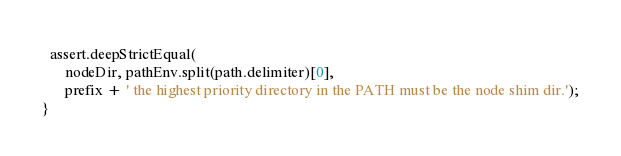Convert code to text. <code><loc_0><loc_0><loc_500><loc_500><_TypeScript_>
  assert.deepStrictEqual(
      nodeDir, pathEnv.split(path.delimiter)[0],
      prefix + ' the highest priority directory in the PATH must be the node shim dir.');
}
</code> 